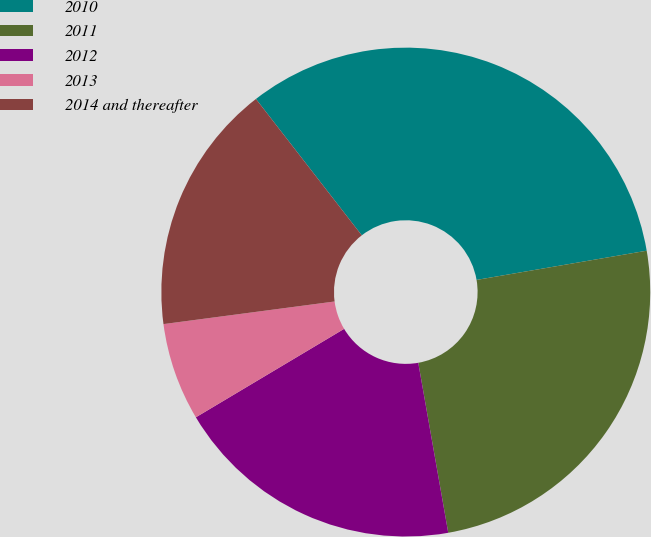<chart> <loc_0><loc_0><loc_500><loc_500><pie_chart><fcel>2010<fcel>2011<fcel>2012<fcel>2013<fcel>2014 and thereafter<nl><fcel>32.8%<fcel>24.93%<fcel>19.22%<fcel>6.47%<fcel>16.59%<nl></chart> 